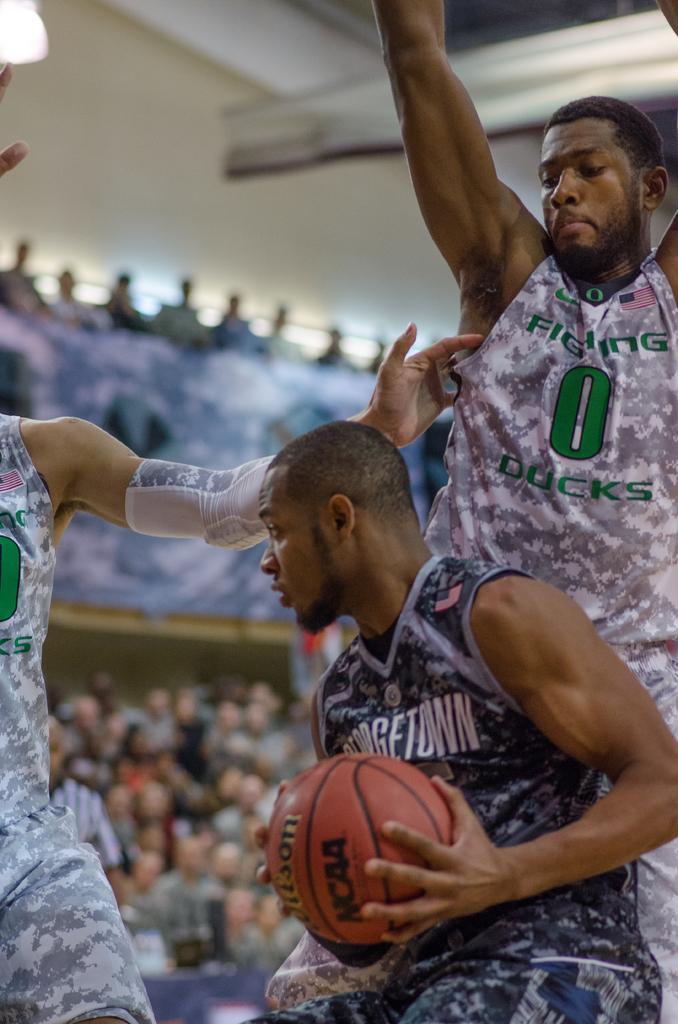How would you summarize this image in a sentence or two? In this image we can see some people. One man is holding a ball in his hands. In the background, we can see group of audience. 